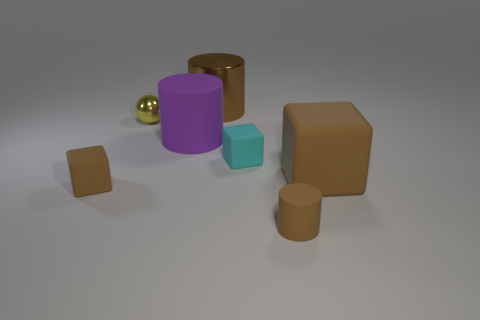Add 3 big metal things. How many objects exist? 10 Subtract all brown cubes. How many cubes are left? 1 Subtract 1 spheres. How many spheres are left? 0 Subtract all green blocks. How many brown cylinders are left? 2 Subtract all cyan matte blocks. Subtract all big blocks. How many objects are left? 5 Add 5 cyan matte blocks. How many cyan matte blocks are left? 6 Add 1 cyan blocks. How many cyan blocks exist? 2 Subtract all brown cylinders. How many cylinders are left? 1 Subtract 0 gray cubes. How many objects are left? 7 Subtract all blocks. How many objects are left? 4 